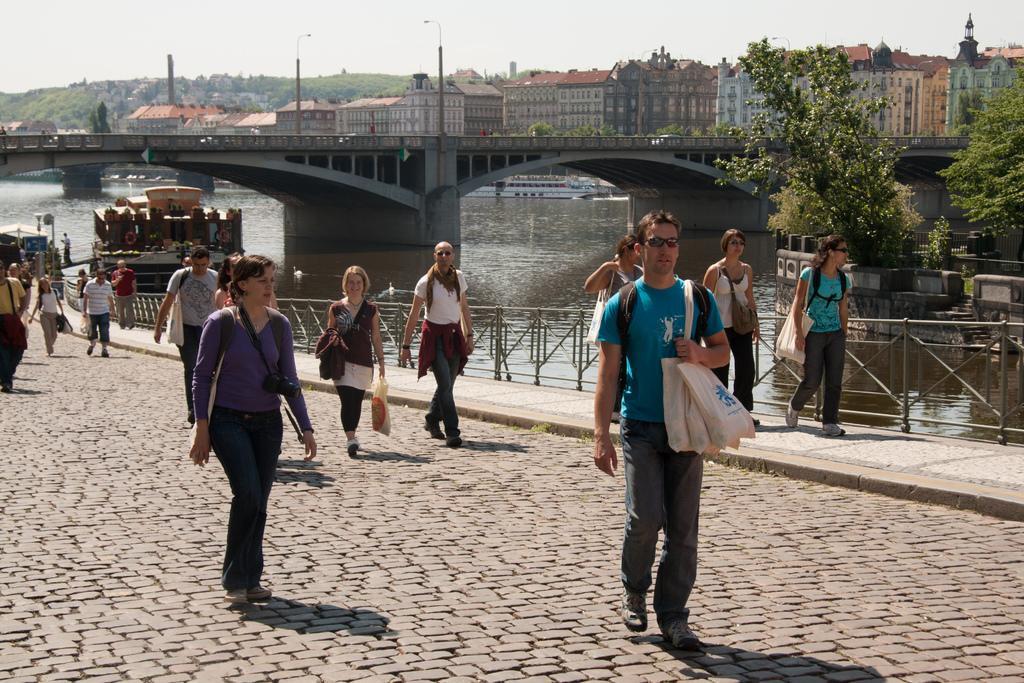Describe this image in one or two sentences. In this image there is a path on that path people are waking, beside the path there is a fencing, in the background there is a river, in that river there is a boat, bridge, trees, houses, mountains and a sky. 